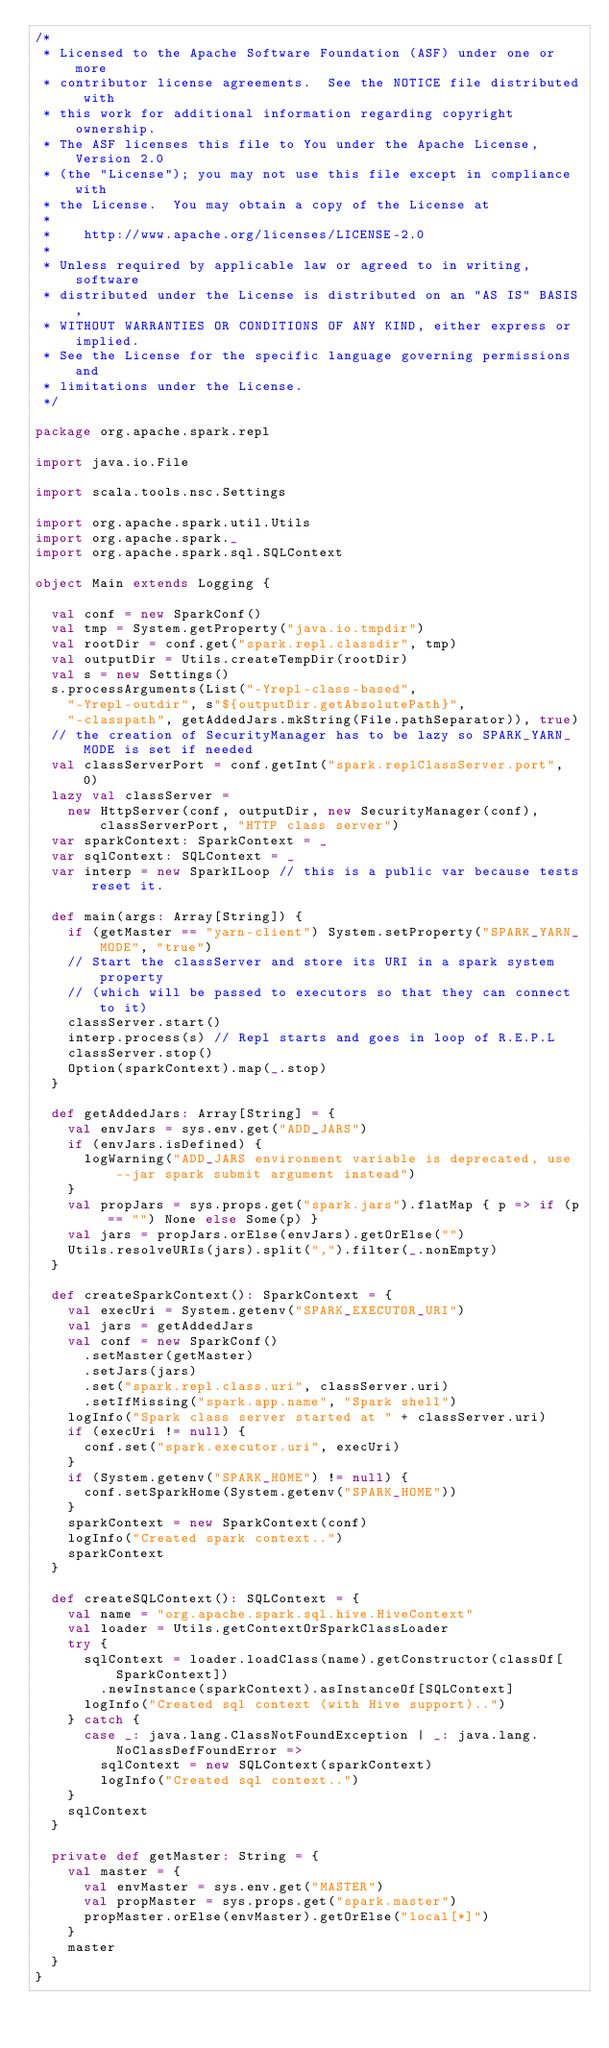<code> <loc_0><loc_0><loc_500><loc_500><_Scala_>/*
 * Licensed to the Apache Software Foundation (ASF) under one or more
 * contributor license agreements.  See the NOTICE file distributed with
 * this work for additional information regarding copyright ownership.
 * The ASF licenses this file to You under the Apache License, Version 2.0
 * (the "License"); you may not use this file except in compliance with
 * the License.  You may obtain a copy of the License at
 *
 *    http://www.apache.org/licenses/LICENSE-2.0
 *
 * Unless required by applicable law or agreed to in writing, software
 * distributed under the License is distributed on an "AS IS" BASIS,
 * WITHOUT WARRANTIES OR CONDITIONS OF ANY KIND, either express or implied.
 * See the License for the specific language governing permissions and
 * limitations under the License.
 */

package org.apache.spark.repl

import java.io.File

import scala.tools.nsc.Settings

import org.apache.spark.util.Utils
import org.apache.spark._
import org.apache.spark.sql.SQLContext

object Main extends Logging {

  val conf = new SparkConf()
  val tmp = System.getProperty("java.io.tmpdir")
  val rootDir = conf.get("spark.repl.classdir", tmp)
  val outputDir = Utils.createTempDir(rootDir)
  val s = new Settings()
  s.processArguments(List("-Yrepl-class-based",
    "-Yrepl-outdir", s"${outputDir.getAbsolutePath}",
    "-classpath", getAddedJars.mkString(File.pathSeparator)), true)
  // the creation of SecurityManager has to be lazy so SPARK_YARN_MODE is set if needed
  val classServerPort = conf.getInt("spark.replClassServer.port", 0)
  lazy val classServer =
    new HttpServer(conf, outputDir, new SecurityManager(conf), classServerPort, "HTTP class server")
  var sparkContext: SparkContext = _
  var sqlContext: SQLContext = _
  var interp = new SparkILoop // this is a public var because tests reset it.

  def main(args: Array[String]) {
    if (getMaster == "yarn-client") System.setProperty("SPARK_YARN_MODE", "true")
    // Start the classServer and store its URI in a spark system property
    // (which will be passed to executors so that they can connect to it)
    classServer.start()
    interp.process(s) // Repl starts and goes in loop of R.E.P.L
    classServer.stop()
    Option(sparkContext).map(_.stop)
  }

  def getAddedJars: Array[String] = {
    val envJars = sys.env.get("ADD_JARS")
    if (envJars.isDefined) {
      logWarning("ADD_JARS environment variable is deprecated, use --jar spark submit argument instead")
    }
    val propJars = sys.props.get("spark.jars").flatMap { p => if (p == "") None else Some(p) }
    val jars = propJars.orElse(envJars).getOrElse("")
    Utils.resolveURIs(jars).split(",").filter(_.nonEmpty)
  }

  def createSparkContext(): SparkContext = {
    val execUri = System.getenv("SPARK_EXECUTOR_URI")
    val jars = getAddedJars
    val conf = new SparkConf()
      .setMaster(getMaster)
      .setJars(jars)
      .set("spark.repl.class.uri", classServer.uri)
      .setIfMissing("spark.app.name", "Spark shell")
    logInfo("Spark class server started at " + classServer.uri)
    if (execUri != null) {
      conf.set("spark.executor.uri", execUri)
    }
    if (System.getenv("SPARK_HOME") != null) {
      conf.setSparkHome(System.getenv("SPARK_HOME"))
    }
    sparkContext = new SparkContext(conf)
    logInfo("Created spark context..")
    sparkContext
  }

  def createSQLContext(): SQLContext = {
    val name = "org.apache.spark.sql.hive.HiveContext"
    val loader = Utils.getContextOrSparkClassLoader
    try {
      sqlContext = loader.loadClass(name).getConstructor(classOf[SparkContext])
        .newInstance(sparkContext).asInstanceOf[SQLContext]
      logInfo("Created sql context (with Hive support)..")
    } catch {
      case _: java.lang.ClassNotFoundException | _: java.lang.NoClassDefFoundError =>
        sqlContext = new SQLContext(sparkContext)
        logInfo("Created sql context..")
    }
    sqlContext
  }

  private def getMaster: String = {
    val master = {
      val envMaster = sys.env.get("MASTER")
      val propMaster = sys.props.get("spark.master")
      propMaster.orElse(envMaster).getOrElse("local[*]")
    }
    master
  }
}
</code> 